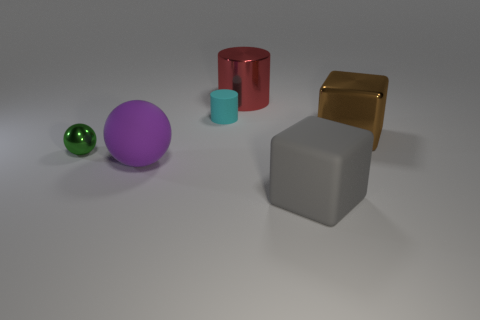There is a big purple thing that is in front of the cyan cylinder; what is its material?
Make the answer very short. Rubber. What number of big things are either yellow rubber cubes or gray matte cubes?
Offer a terse response. 1. Are there any small green objects made of the same material as the cyan object?
Provide a succinct answer. No. There is a cylinder in front of the red metallic thing; does it have the same size as the metallic cube?
Offer a very short reply. No. Are there any large blocks in front of the metal thing that is in front of the large cube behind the small metallic sphere?
Your answer should be very brief. Yes. How many matte things are either gray cubes or small cyan balls?
Provide a short and direct response. 1. What number of other objects are there of the same shape as the brown shiny thing?
Keep it short and to the point. 1. Are there more brown shiny cylinders than gray matte objects?
Your response must be concise. No. There is a rubber object on the right side of the large metallic thing to the left of the big block in front of the metallic ball; what size is it?
Your response must be concise. Large. There is a object that is in front of the purple rubber thing; how big is it?
Your response must be concise. Large. 